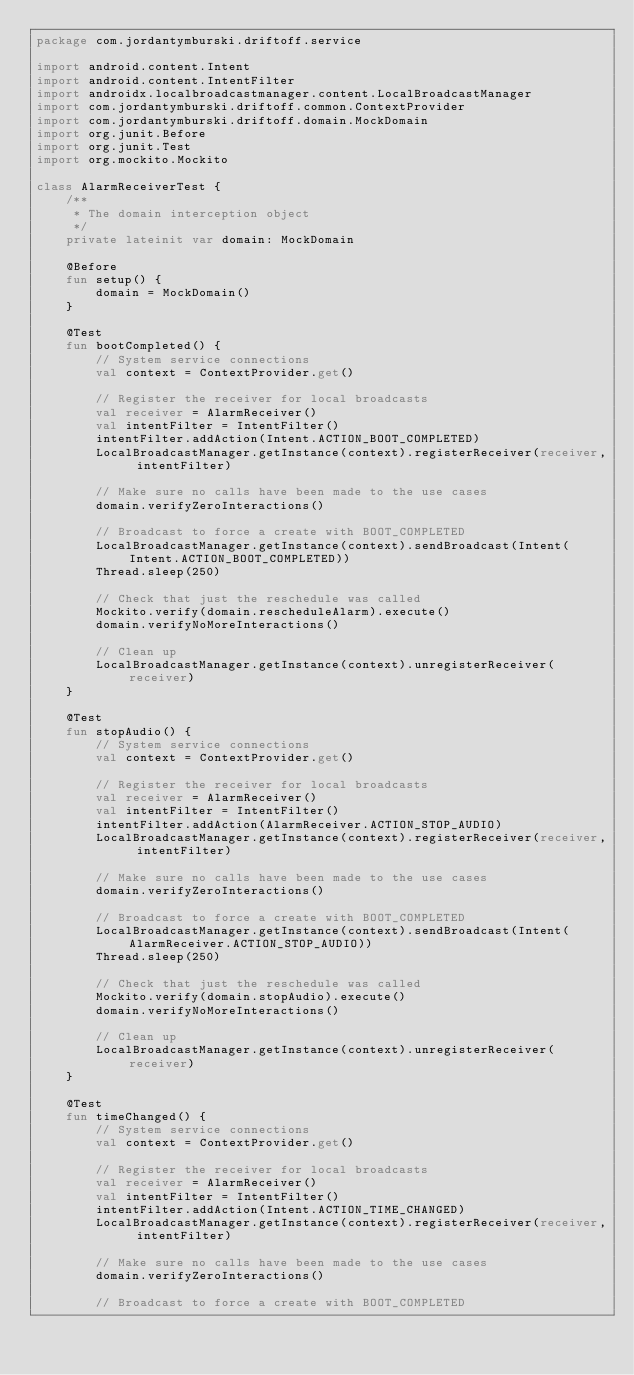Convert code to text. <code><loc_0><loc_0><loc_500><loc_500><_Kotlin_>package com.jordantymburski.driftoff.service

import android.content.Intent
import android.content.IntentFilter
import androidx.localbroadcastmanager.content.LocalBroadcastManager
import com.jordantymburski.driftoff.common.ContextProvider
import com.jordantymburski.driftoff.domain.MockDomain
import org.junit.Before
import org.junit.Test
import org.mockito.Mockito

class AlarmReceiverTest {
    /**
     * The domain interception object
     */
    private lateinit var domain: MockDomain

    @Before
    fun setup() {
        domain = MockDomain()
    }

    @Test
    fun bootCompleted() {
        // System service connections
        val context = ContextProvider.get()

        // Register the receiver for local broadcasts
        val receiver = AlarmReceiver()
        val intentFilter = IntentFilter()
        intentFilter.addAction(Intent.ACTION_BOOT_COMPLETED)
        LocalBroadcastManager.getInstance(context).registerReceiver(receiver, intentFilter)

        // Make sure no calls have been made to the use cases
        domain.verifyZeroInteractions()

        // Broadcast to force a create with BOOT_COMPLETED
        LocalBroadcastManager.getInstance(context).sendBroadcast(Intent(Intent.ACTION_BOOT_COMPLETED))
        Thread.sleep(250)

        // Check that just the reschedule was called
        Mockito.verify(domain.rescheduleAlarm).execute()
        domain.verifyNoMoreInteractions()

        // Clean up
        LocalBroadcastManager.getInstance(context).unregisterReceiver(receiver)
    }

    @Test
    fun stopAudio() {
        // System service connections
        val context = ContextProvider.get()

        // Register the receiver for local broadcasts
        val receiver = AlarmReceiver()
        val intentFilter = IntentFilter()
        intentFilter.addAction(AlarmReceiver.ACTION_STOP_AUDIO)
        LocalBroadcastManager.getInstance(context).registerReceiver(receiver, intentFilter)

        // Make sure no calls have been made to the use cases
        domain.verifyZeroInteractions()

        // Broadcast to force a create with BOOT_COMPLETED
        LocalBroadcastManager.getInstance(context).sendBroadcast(Intent(AlarmReceiver.ACTION_STOP_AUDIO))
        Thread.sleep(250)

        // Check that just the reschedule was called
        Mockito.verify(domain.stopAudio).execute()
        domain.verifyNoMoreInteractions()

        // Clean up
        LocalBroadcastManager.getInstance(context).unregisterReceiver(receiver)
    }

    @Test
    fun timeChanged() {
        // System service connections
        val context = ContextProvider.get()

        // Register the receiver for local broadcasts
        val receiver = AlarmReceiver()
        val intentFilter = IntentFilter()
        intentFilter.addAction(Intent.ACTION_TIME_CHANGED)
        LocalBroadcastManager.getInstance(context).registerReceiver(receiver, intentFilter)

        // Make sure no calls have been made to the use cases
        domain.verifyZeroInteractions()

        // Broadcast to force a create with BOOT_COMPLETED</code> 